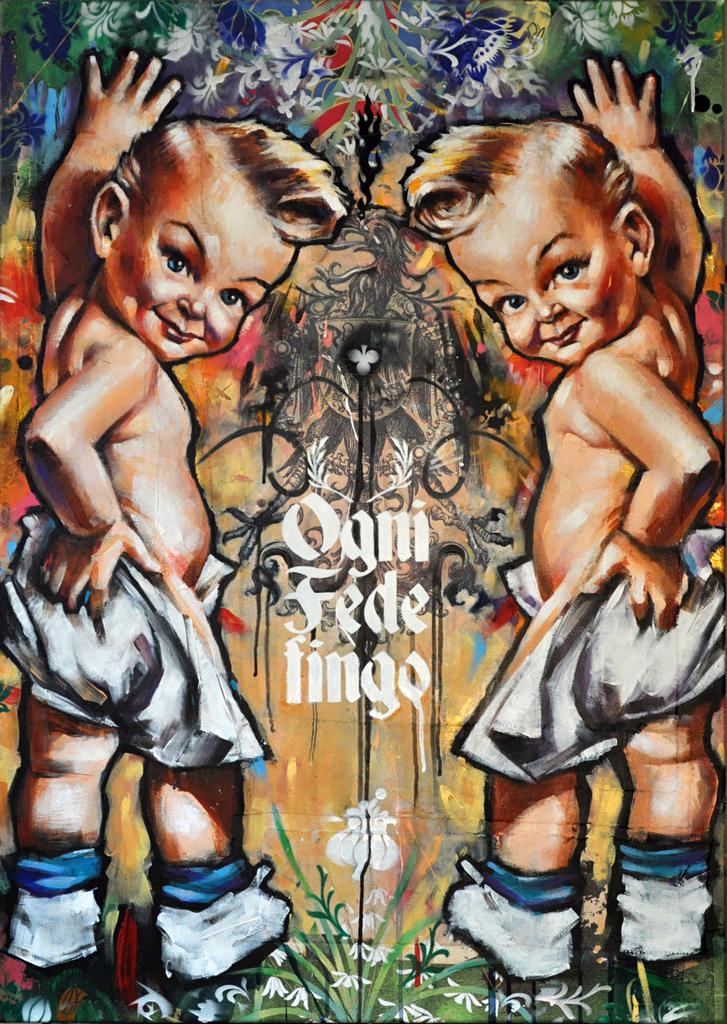Could you give a brief overview of what you see in this image? Here in this picture we can see a painting of two babies standing over a place and in the middle we can see some text written over there. 